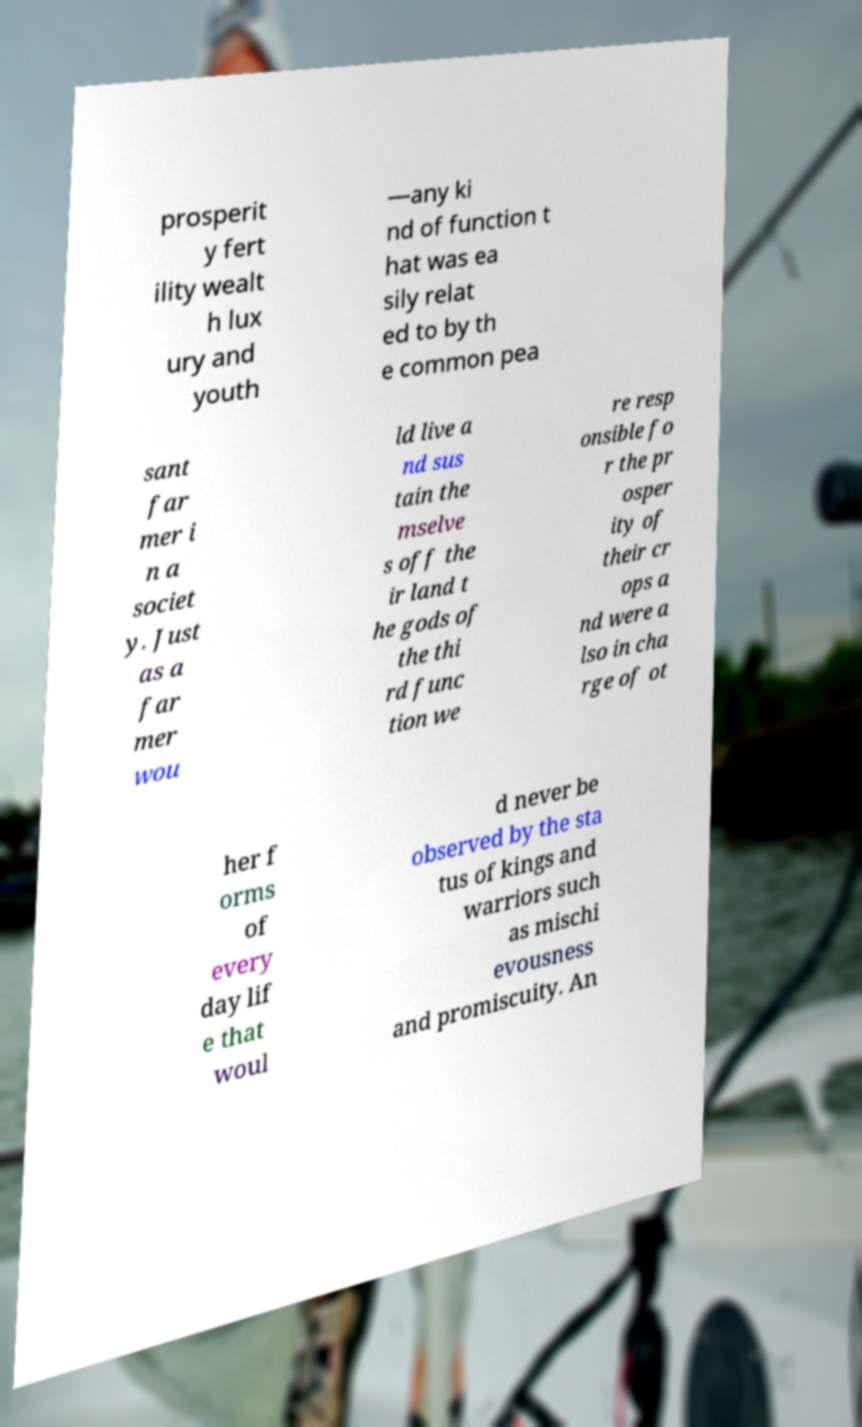There's text embedded in this image that I need extracted. Can you transcribe it verbatim? prosperit y fert ility wealt h lux ury and youth —any ki nd of function t hat was ea sily relat ed to by th e common pea sant far mer i n a societ y. Just as a far mer wou ld live a nd sus tain the mselve s off the ir land t he gods of the thi rd func tion we re resp onsible fo r the pr osper ity of their cr ops a nd were a lso in cha rge of ot her f orms of every day lif e that woul d never be observed by the sta tus of kings and warriors such as mischi evousness and promiscuity. An 